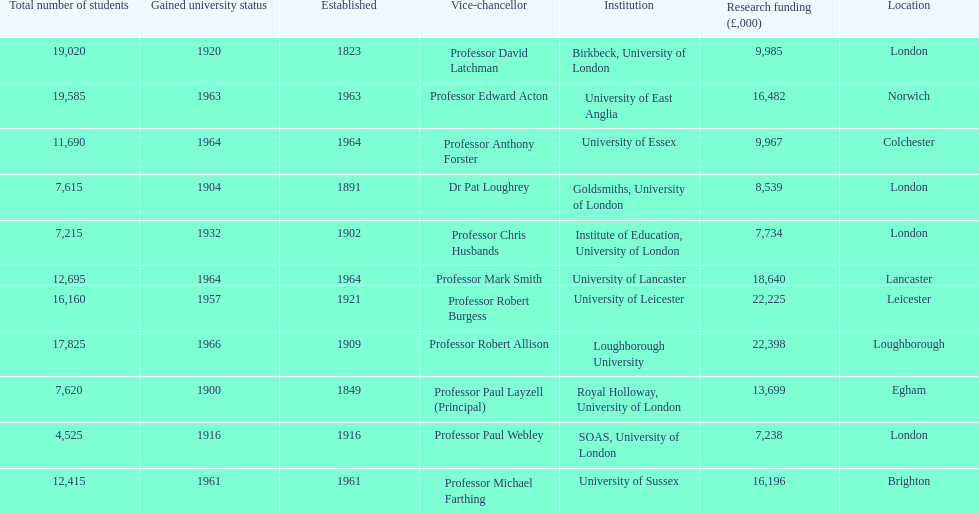What is the most recent institution to gain university status? Loughborough University. 